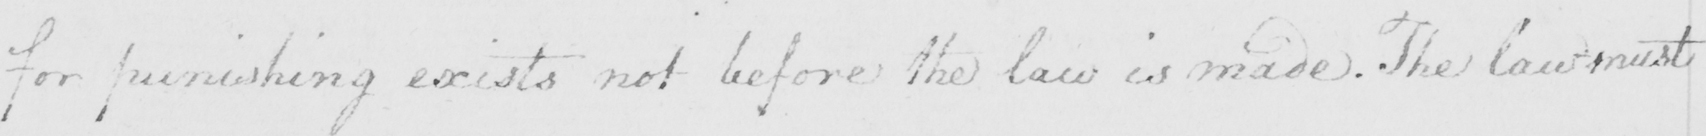What text is written in this handwritten line? for punishing exists not before the law is made . The law must 